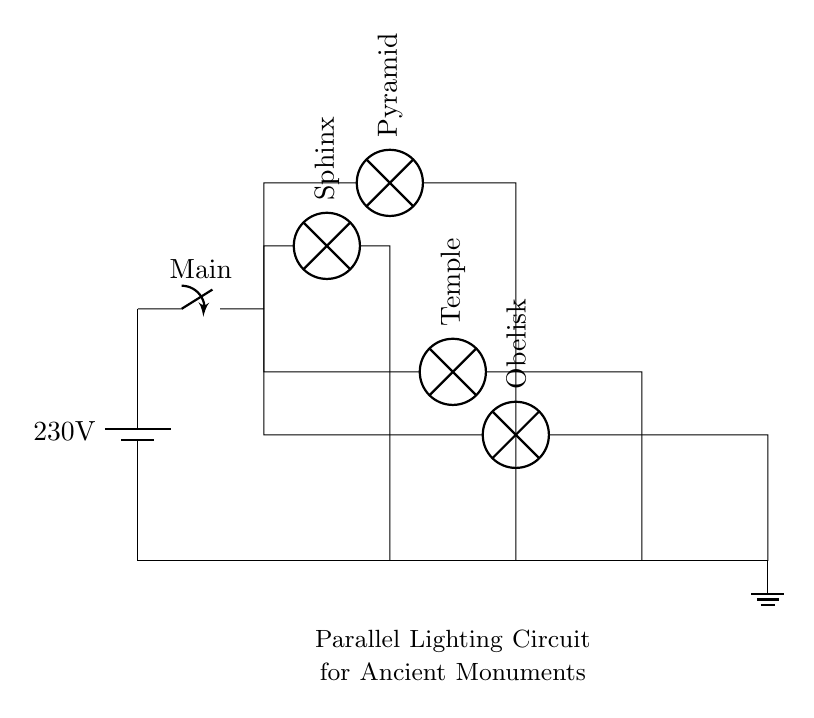What is the voltage of the power source? The circuit indicates a power source labeled as a battery, which has a voltage of 230 volts. This means that the potential difference supplied to the circuit is 230 volts.
Answer: 230 volts What is the function of the main switch? The main switch is used to control the overall operation of the lighting circuit. If the switch is closed, it allows current to flow to all the branches, illuminating the lamps. If opened, it interrupts the flow, turning all lights off.
Answer: To control the entire circuit How many lamps are connected in parallel? The circuit diagram shows a total of four lamps connected in parallel branching from the main circuit. Each lamp is illuminated independently of the others, which is a key characteristic of parallel circuits.
Answer: Four lamps What type of circuit is this? The circuit is classified as a parallel lighting circuit. In this configuration, each lamp is connected across the same two points of the power source, allowing for independent operation of each lamp.
Answer: Parallel circuit What happens if one lamp fails? In a parallel circuit, if one lamp fails or goes out, the others remain illuminated because they are all connected to the same voltage source independently. The failure of one does not affect the operation of the rest.
Answer: Others remain lit What is the significance of the ground in this circuit? The ground provides a reference point for the circuit and acts as a safety measure. It helps to prevent any accidental shock to users by ensuring that any fault current has a safe path to the earth.
Answer: Safety reference 